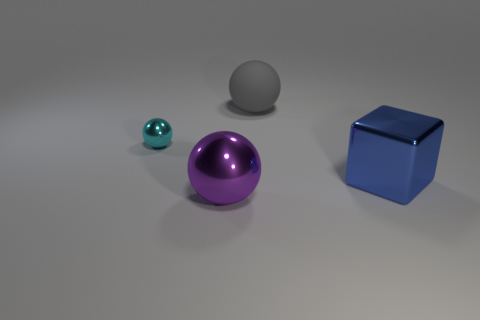Subtract all small balls. How many balls are left? 2 Add 1 small yellow things. How many objects exist? 5 Subtract all cubes. How many objects are left? 3 Subtract all blue spheres. Subtract all brown cylinders. How many spheres are left? 3 Add 1 rubber objects. How many rubber objects are left? 2 Add 3 tiny purple metal cylinders. How many tiny purple metal cylinders exist? 3 Subtract 0 green blocks. How many objects are left? 4 Subtract all blue things. Subtract all cyan cylinders. How many objects are left? 3 